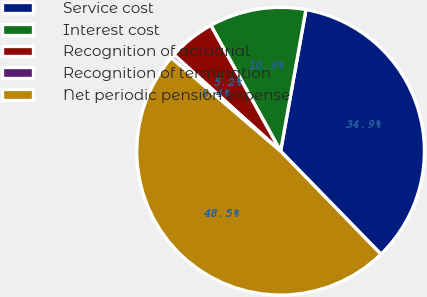Convert chart to OTSL. <chart><loc_0><loc_0><loc_500><loc_500><pie_chart><fcel>Service cost<fcel>Interest cost<fcel>Recognition of actuarial<fcel>Recognition of termination<fcel>Net periodic pension expense<nl><fcel>34.89%<fcel>10.88%<fcel>5.25%<fcel>0.44%<fcel>48.55%<nl></chart> 